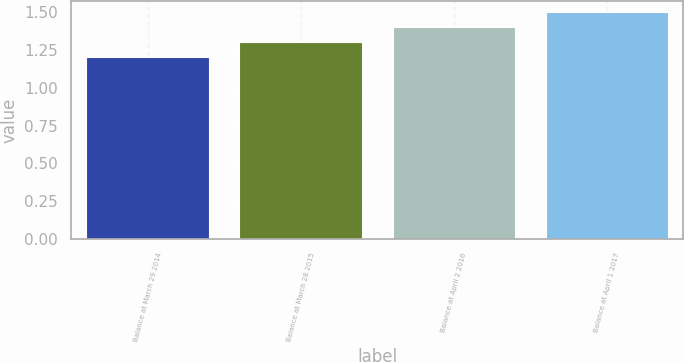<chart> <loc_0><loc_0><loc_500><loc_500><bar_chart><fcel>Balance at March 29 2014<fcel>Balance at March 28 2015<fcel>Balance at April 2 2016<fcel>Balance at April 1 2017<nl><fcel>1.2<fcel>1.3<fcel>1.4<fcel>1.5<nl></chart> 